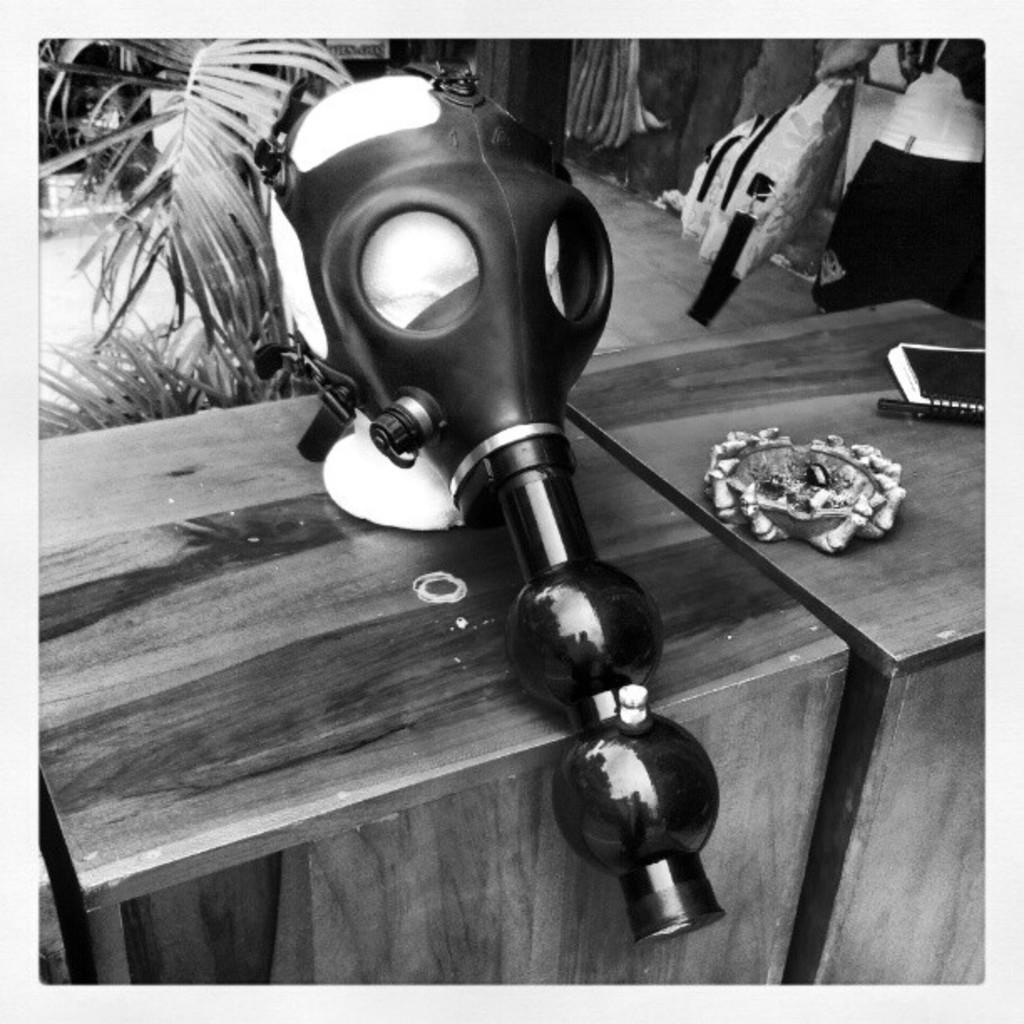What is on the table in the image? There is a book and a mask on the table. Are there any other items on the table? Yes, there are other things on the table. What can be seen in the background of the image? There are plants in the background of the image. What degree does the book on the table have? The book on the table does not have a degree, as it is an inanimate object and degrees are academic qualifications awarded to individuals. 